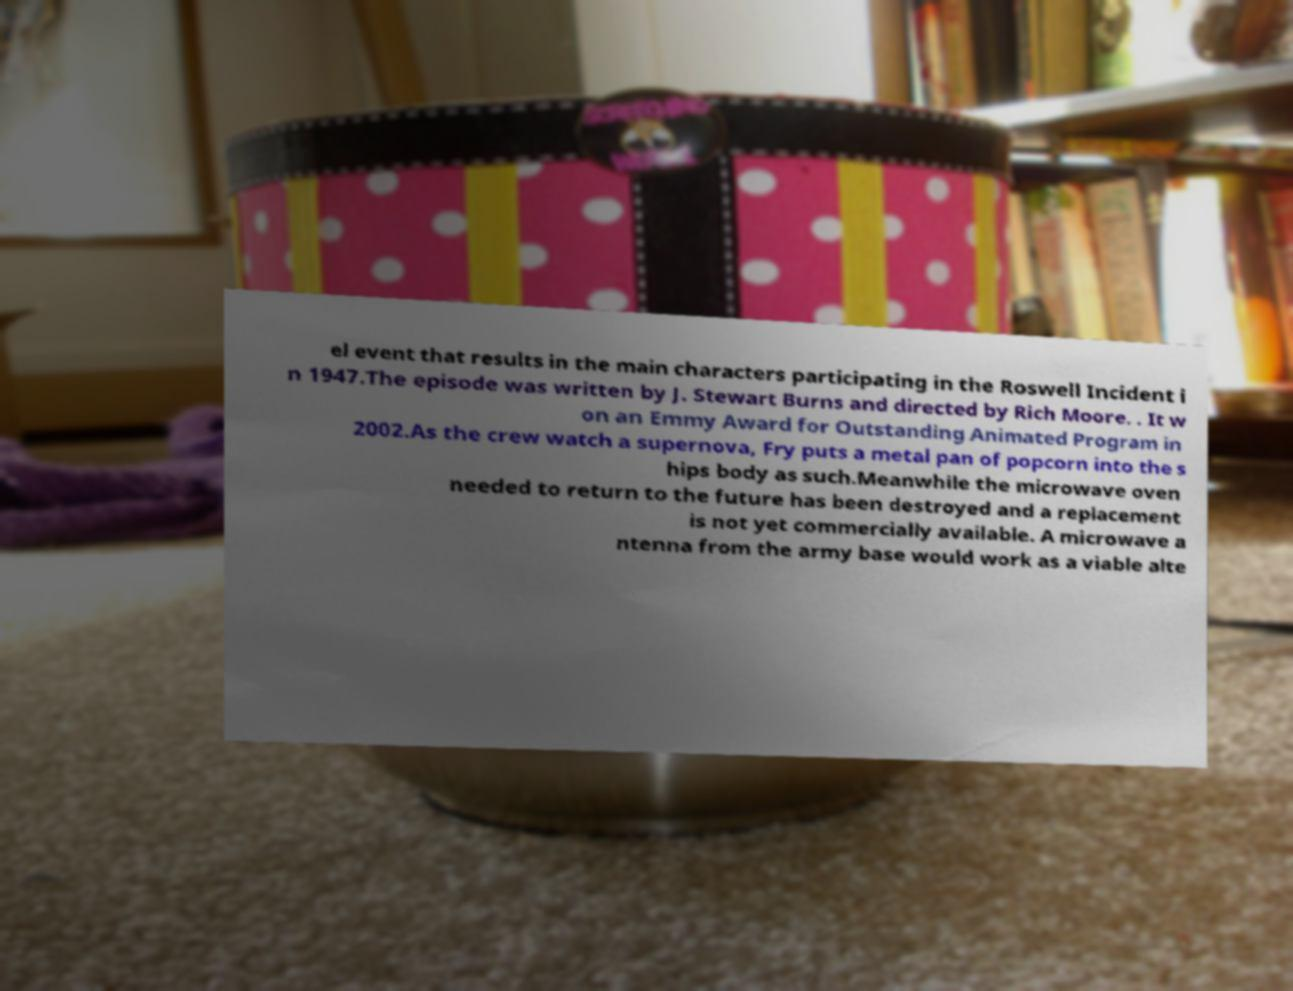Please identify and transcribe the text found in this image. el event that results in the main characters participating in the Roswell Incident i n 1947.The episode was written by J. Stewart Burns and directed by Rich Moore. . It w on an Emmy Award for Outstanding Animated Program in 2002.As the crew watch a supernova, Fry puts a metal pan of popcorn into the s hips body as such.Meanwhile the microwave oven needed to return to the future has been destroyed and a replacement is not yet commercially available. A microwave a ntenna from the army base would work as a viable alte 